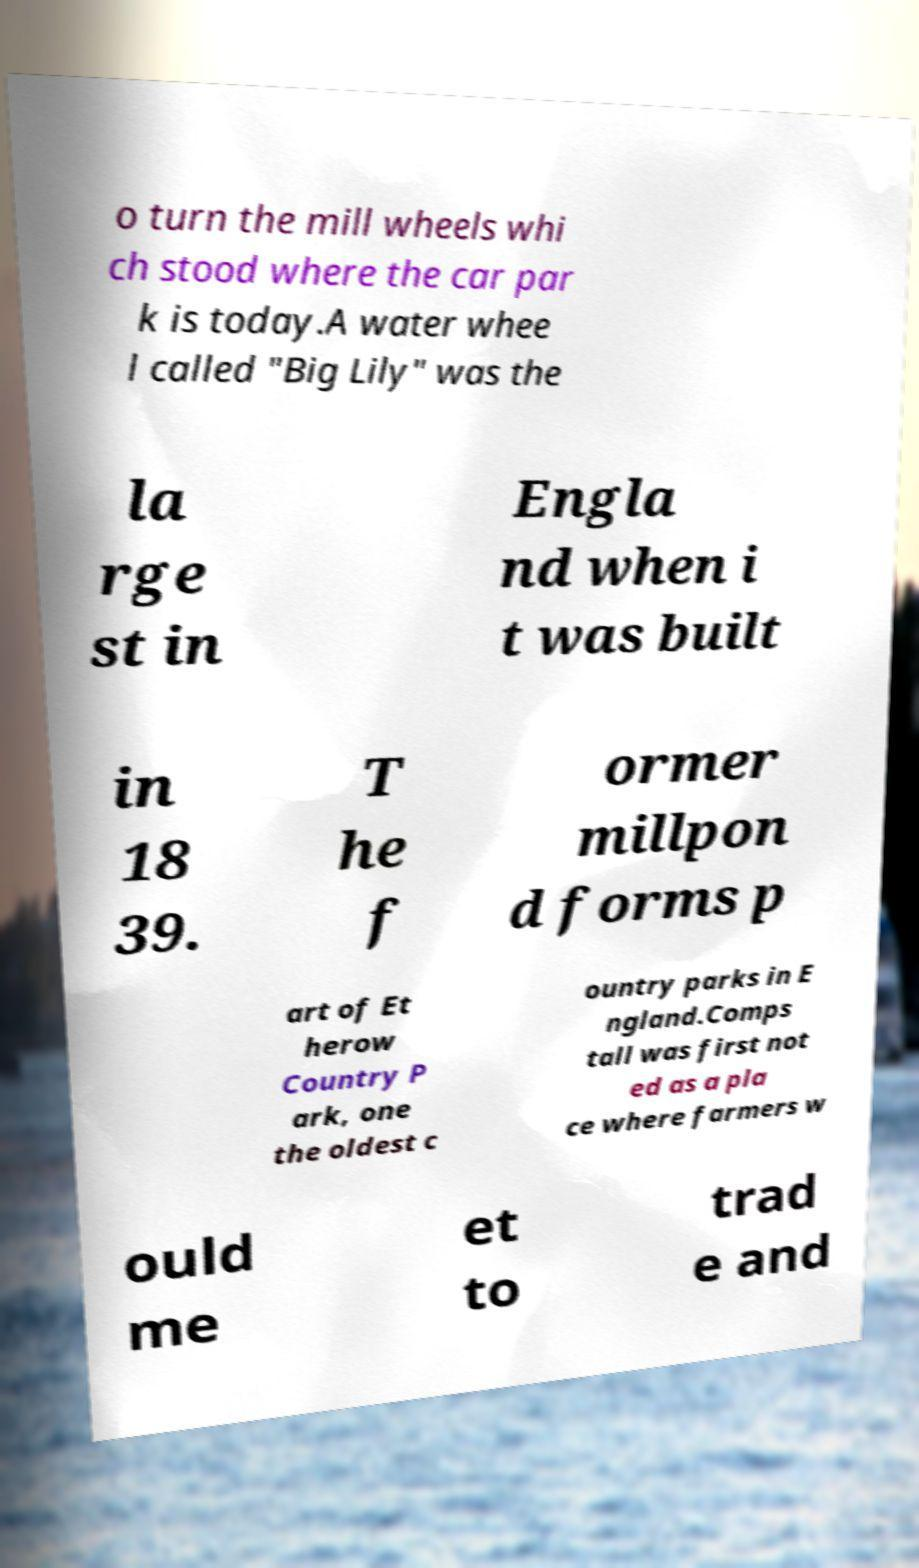Please read and relay the text visible in this image. What does it say? o turn the mill wheels whi ch stood where the car par k is today.A water whee l called "Big Lily" was the la rge st in Engla nd when i t was built in 18 39. T he f ormer millpon d forms p art of Et herow Country P ark, one the oldest c ountry parks in E ngland.Comps tall was first not ed as a pla ce where farmers w ould me et to trad e and 